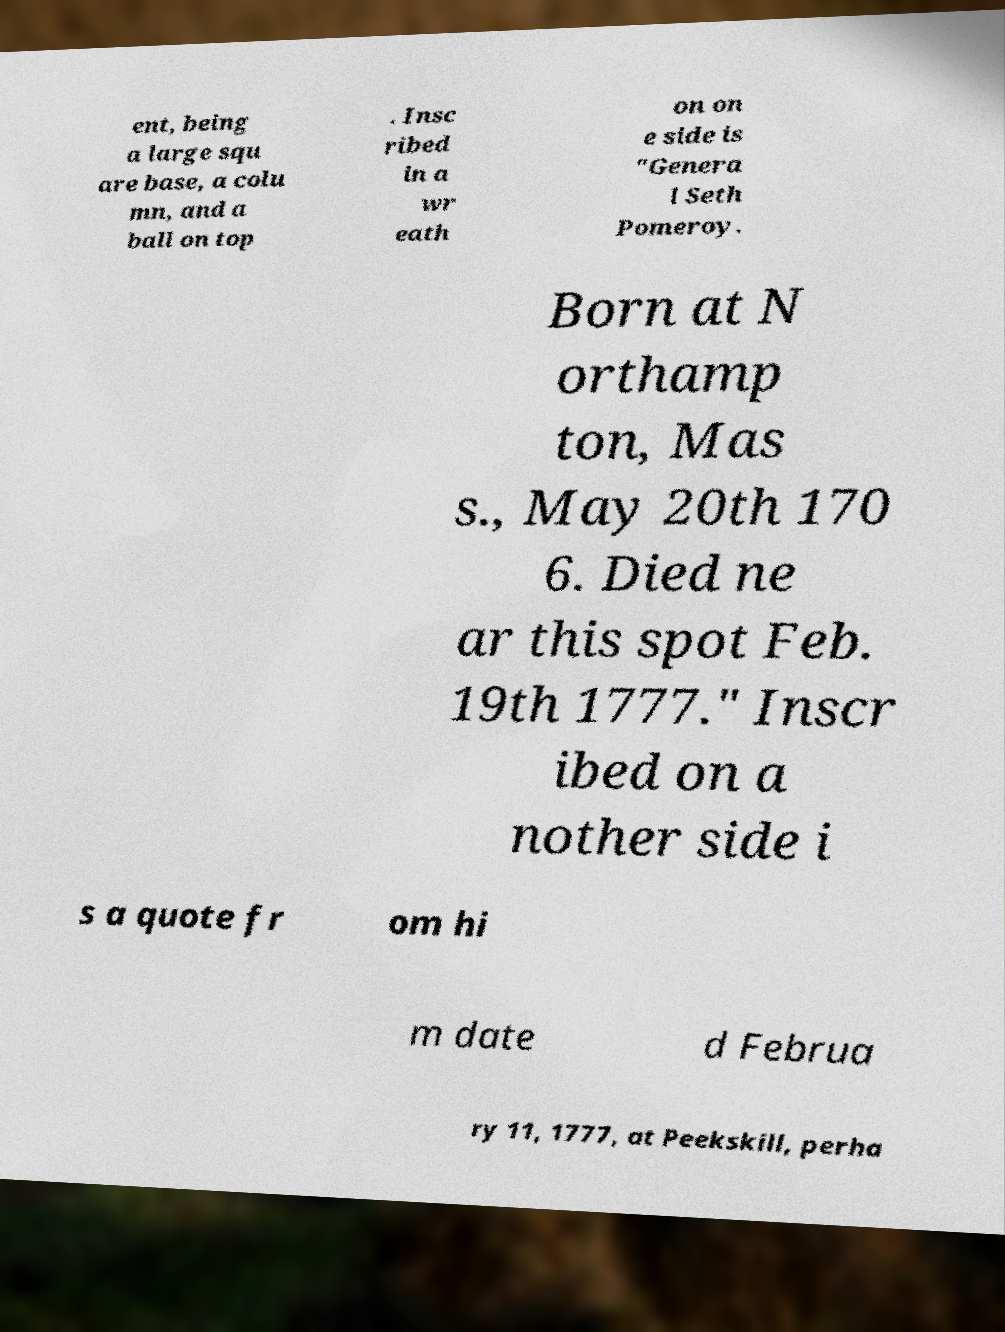Please identify and transcribe the text found in this image. ent, being a large squ are base, a colu mn, and a ball on top . Insc ribed in a wr eath on on e side is "Genera l Seth Pomeroy. Born at N orthamp ton, Mas s., May 20th 170 6. Died ne ar this spot Feb. 19th 1777." Inscr ibed on a nother side i s a quote fr om hi m date d Februa ry 11, 1777, at Peekskill, perha 